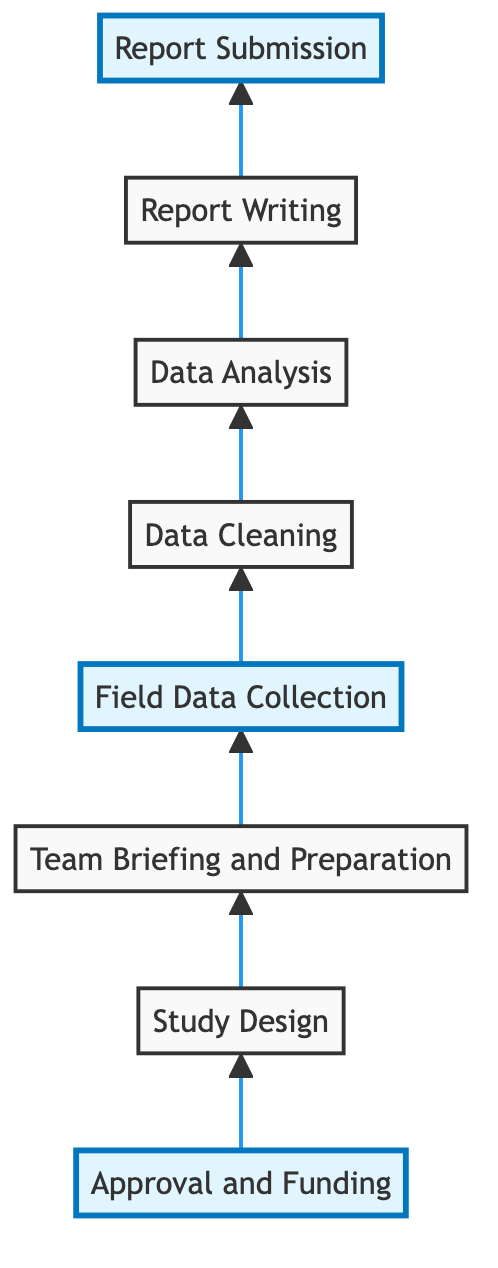What is the last step before report submission? The last step indicated before the "Report Submission" is "Report Writing." This is the penultimate stage where the compiled analyses and discussions are put into a final report format.
Answer: Report Writing Which step comes immediately after field data collection? Immediately following "Field Data Collection" is "Data Cleaning." The diagram clearly shows this sequential relationship where data collected needs to be processed and cleaned to ensure it is usable for analysis.
Answer: Data Cleaning How many steps are presented in the flow chart? The flow chart includes a total of eight steps, from "Approval and Funding" at the bottom to "Report Submission" at the top. Each step is represented distinctly within the diagram.
Answer: Eight What step involves preparing the team? The step labeled "Team Briefing and Preparation" is responsible for preparing the team with the necessary tools and information for data collection. It is crucial for ensuring that the team is ready before collecting any data.
Answer: Team Briefing and Preparation What is the first step in the study process? The first step in the study process, as indicated by the bottom of the flow chart, is "Approval and Funding." This step must be completed to move forward with all subsequent activities related to the study.
Answer: Approval and Funding Which step appears to be highlighted in the chart? The steps that are highlighted in the chart include "Approval and Funding," "Field Data Collection," and "Report Submission." These highlighted boxes suggest importance, possibly due to their critical roles in the process.
Answer: Approval and Funding, Field Data Collection, Report Submission What step follows after data analysis? The step that follows "Data Analysis" in the flow chart is "Report Writing." This indicates that once the data has been analyzed, the next action is to compile everything into a coherent report.
Answer: Report Writing What is the relationship between data cleaning and report writing? The relationship is sequential. "Data Cleaning" must occur before "Report Writing" can take place, as the cleaned data is essential to developing the report based on accurate analyses.
Answer: Sequential relationship 